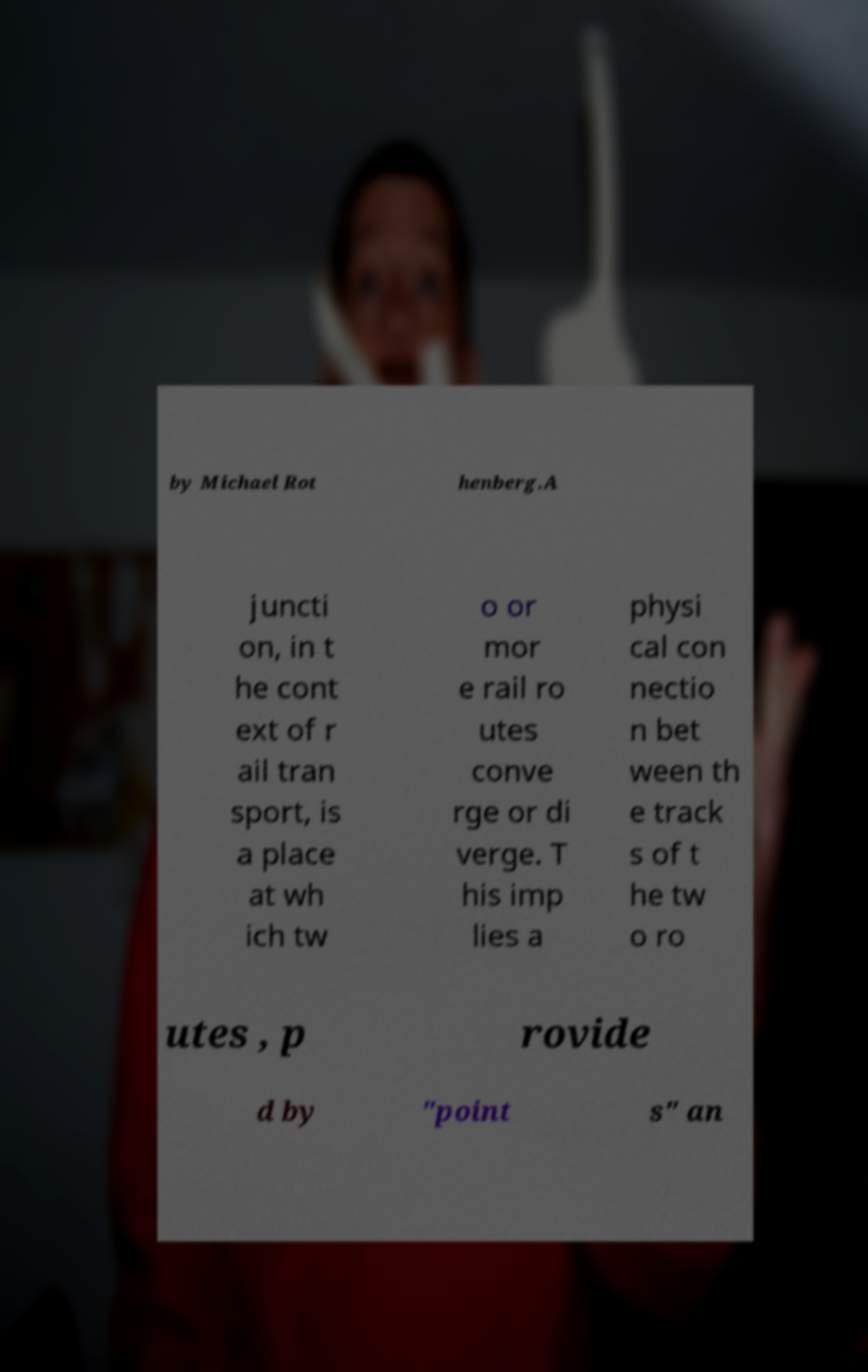Could you assist in decoding the text presented in this image and type it out clearly? by Michael Rot henberg.A juncti on, in t he cont ext of r ail tran sport, is a place at wh ich tw o or mor e rail ro utes conve rge or di verge. T his imp lies a physi cal con nectio n bet ween th e track s of t he tw o ro utes , p rovide d by "point s" an 